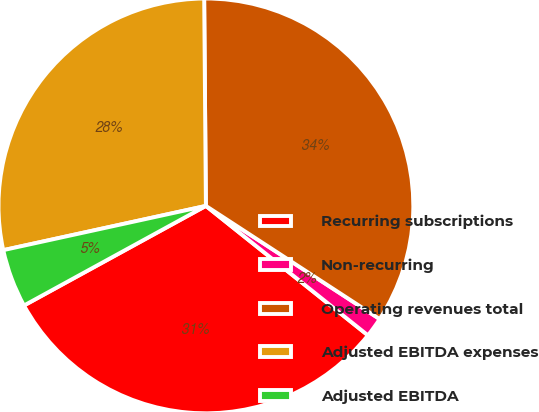Convert chart to OTSL. <chart><loc_0><loc_0><loc_500><loc_500><pie_chart><fcel>Recurring subscriptions<fcel>Non-recurring<fcel>Operating revenues total<fcel>Adjusted EBITDA expenses<fcel>Adjusted EBITDA<nl><fcel>31.3%<fcel>1.54%<fcel>34.32%<fcel>28.29%<fcel>4.55%<nl></chart> 